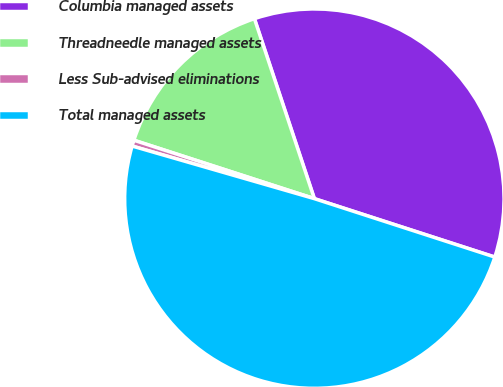<chart> <loc_0><loc_0><loc_500><loc_500><pie_chart><fcel>Columbia managed assets<fcel>Threadneedle managed assets<fcel>Less Sub-advised eliminations<fcel>Total managed assets<nl><fcel>35.1%<fcel>14.9%<fcel>0.51%<fcel>49.49%<nl></chart> 